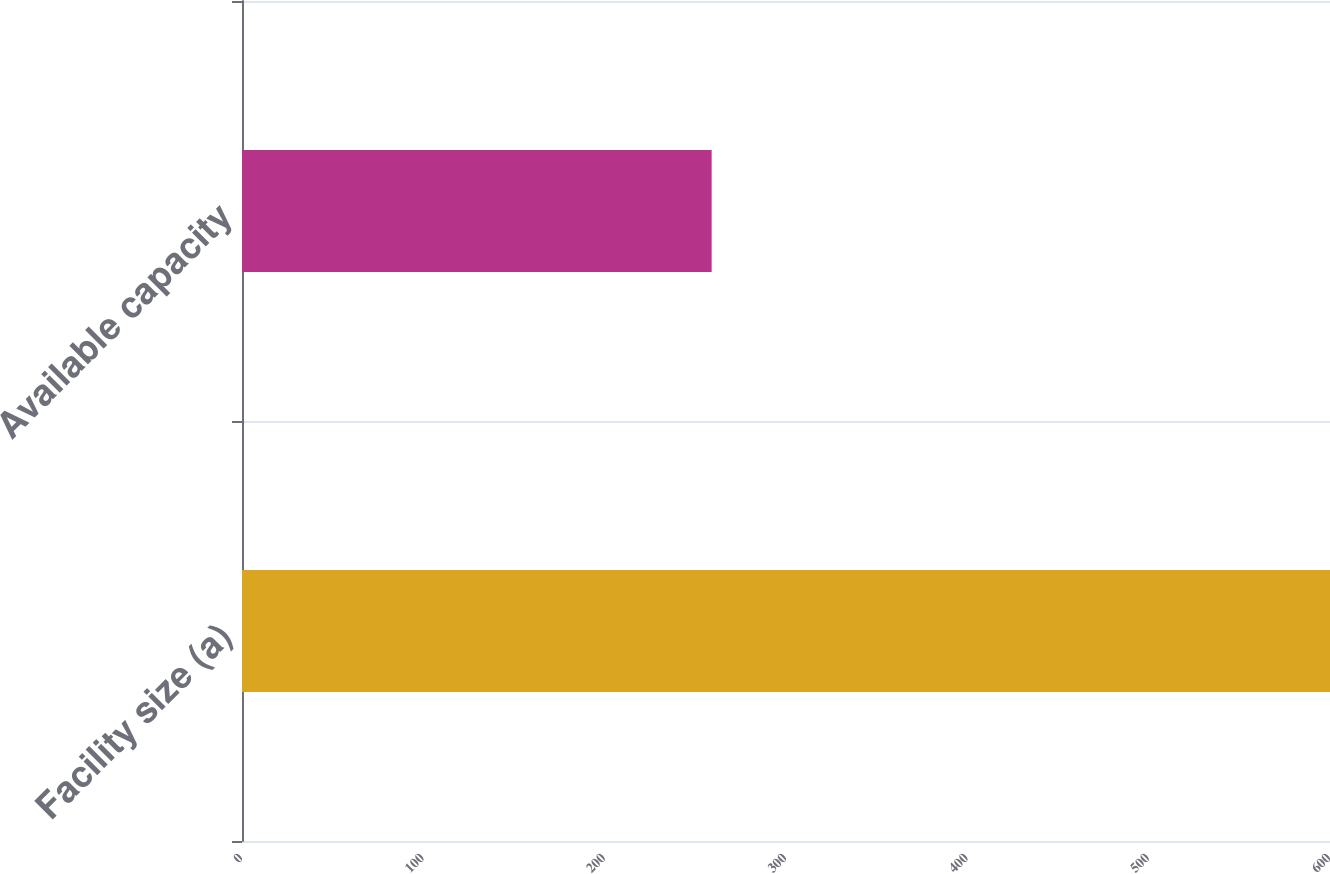<chart> <loc_0><loc_0><loc_500><loc_500><bar_chart><fcel>Facility size (a)<fcel>Available capacity<nl><fcel>600<fcel>259<nl></chart> 